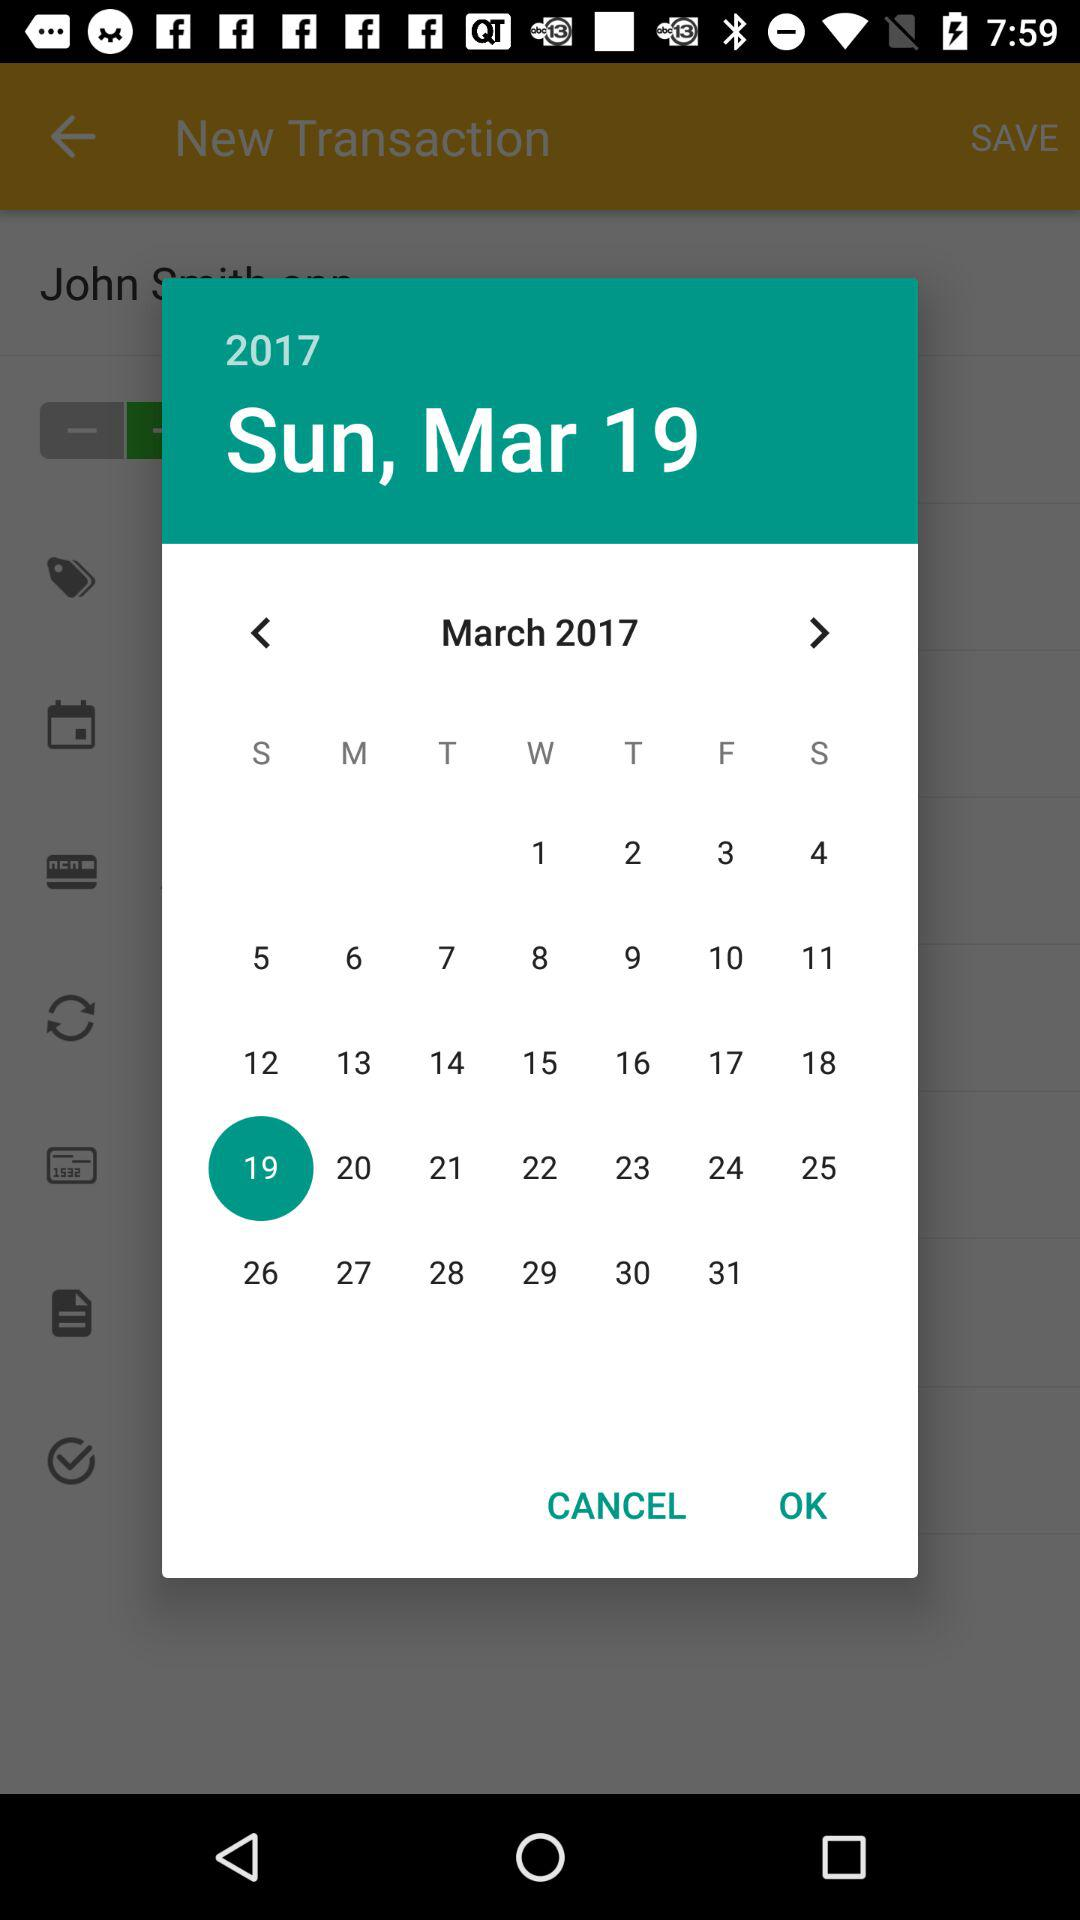What is the selected date? The selected date is Sunday, March 19, 2017. 